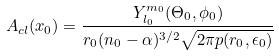Convert formula to latex. <formula><loc_0><loc_0><loc_500><loc_500>A _ { c l } ( { x } _ { 0 } ) = \frac { Y _ { l _ { 0 } } ^ { m _ { 0 } } ( \Theta _ { 0 } , \phi _ { 0 } ) } { r _ { 0 } ( n _ { 0 } - \alpha ) ^ { 3 / 2 } \sqrt { 2 \pi p ( r _ { 0 } , \epsilon _ { 0 } ) } }</formula> 